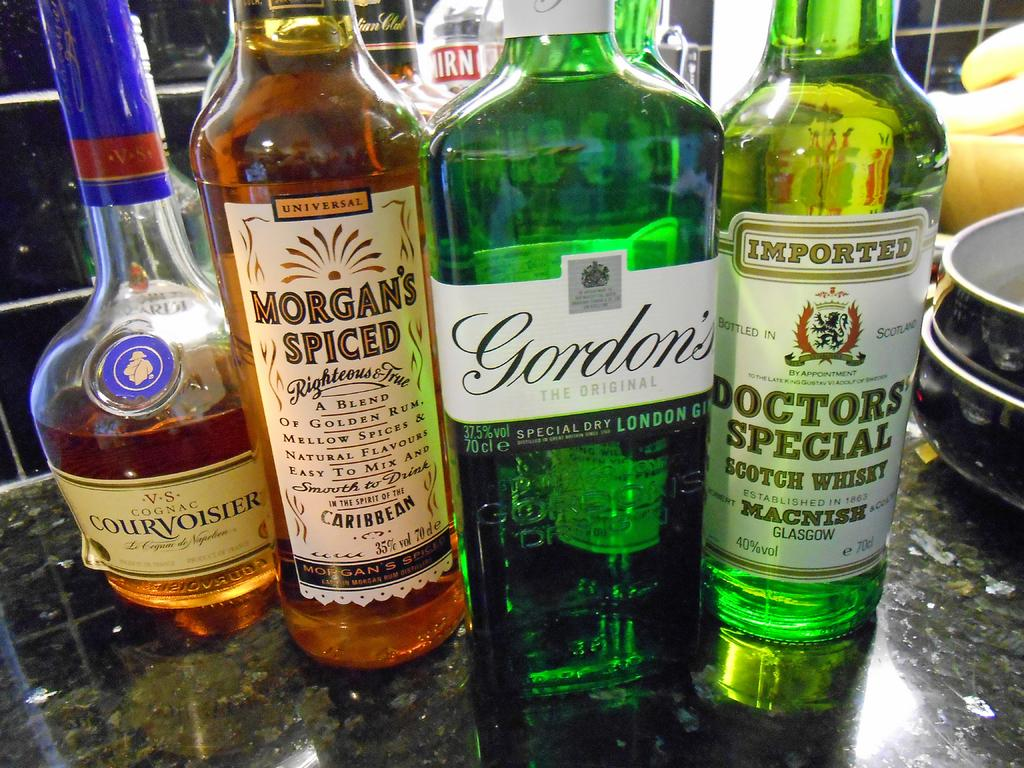<image>
Describe the image concisely. A few bottles of alcohol next to each other with Morgan's Spiced and Gordon's 